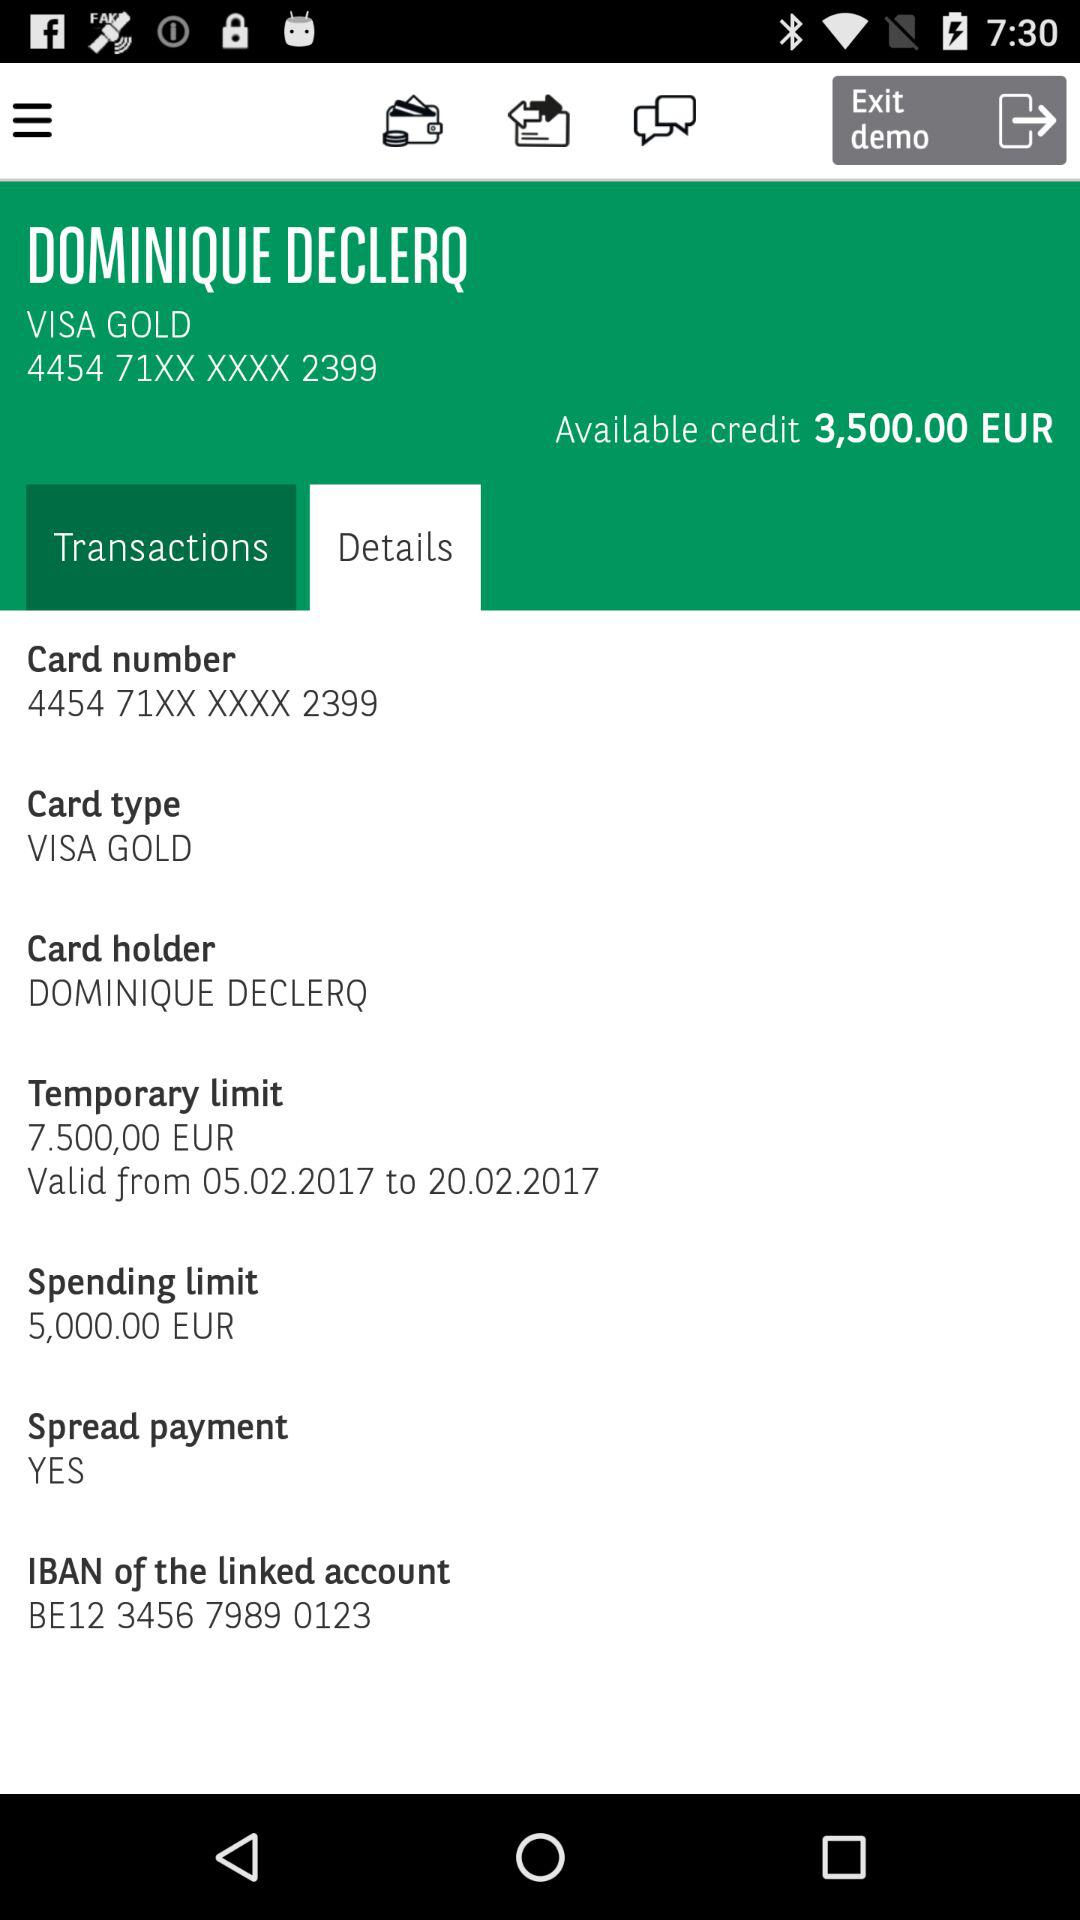What is the mentioned IBAN? The mentioned IBAN is BE12 3456 7989 0123. 